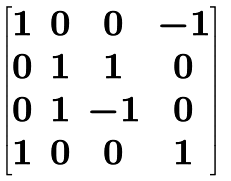Convert formula to latex. <formula><loc_0><loc_0><loc_500><loc_500>\begin{bmatrix} 1 & 0 & 0 & - 1 \\ 0 & 1 & 1 & 0 \\ 0 & 1 & - 1 & 0 \\ 1 & 0 & 0 & 1 \end{bmatrix}</formula> 